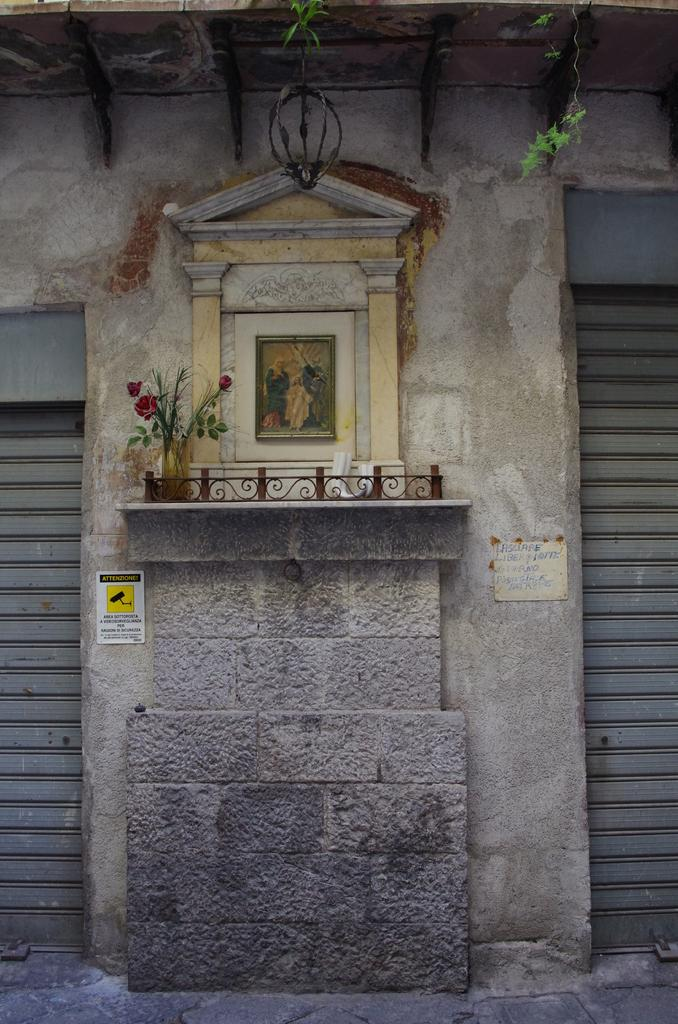What type of window covering is present in the image? There are shutters in the image. What decorative item can be seen in the image? There is a flower vase in the image. What architectural feature is present in the image? There is an iron grille in the image. What type of natural element is visible in the image? Leaves are visible in the image. What is attached to the wall in the image? There are papers and a photo frame on the wall in the image. Where is the can located in the image? There is no can present in the image. What type of mailbox is visible in the image? There is no mailbox present in the image. 